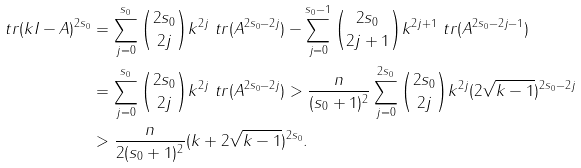<formula> <loc_0><loc_0><loc_500><loc_500>\ t r ( k I - A ) ^ { 2 s _ { 0 } } & = \sum _ { j = 0 } ^ { s _ { 0 } } { 2 s _ { 0 } \choose 2 j } k ^ { 2 j } \ t r ( A ^ { 2 s _ { 0 } - 2 j } ) - \sum _ { j = 0 } ^ { s _ { 0 } - 1 } { 2 s _ { 0 } \choose 2 j + 1 } k ^ { 2 j + 1 } \ t r ( A ^ { 2 s _ { 0 } - 2 j - 1 } ) \\ & = \sum _ { j = 0 } ^ { s _ { 0 } } { 2 s _ { 0 } \choose 2 j } k ^ { 2 j } \ t r ( A ^ { 2 s _ { 0 } - 2 j } ) > \frac { n } { ( s _ { 0 } + 1 ) ^ { 2 } } \sum _ { j = 0 } ^ { 2 s _ { 0 } } { 2 s _ { 0 } \choose 2 j } k ^ { 2 j } ( 2 \sqrt { k - 1 } ) ^ { 2 s _ { 0 } - 2 j } \\ & > \frac { n } { 2 ( s _ { 0 } + 1 ) ^ { 2 } } ( k + 2 \sqrt { k - 1 } ) ^ { 2 s _ { 0 } } .</formula> 